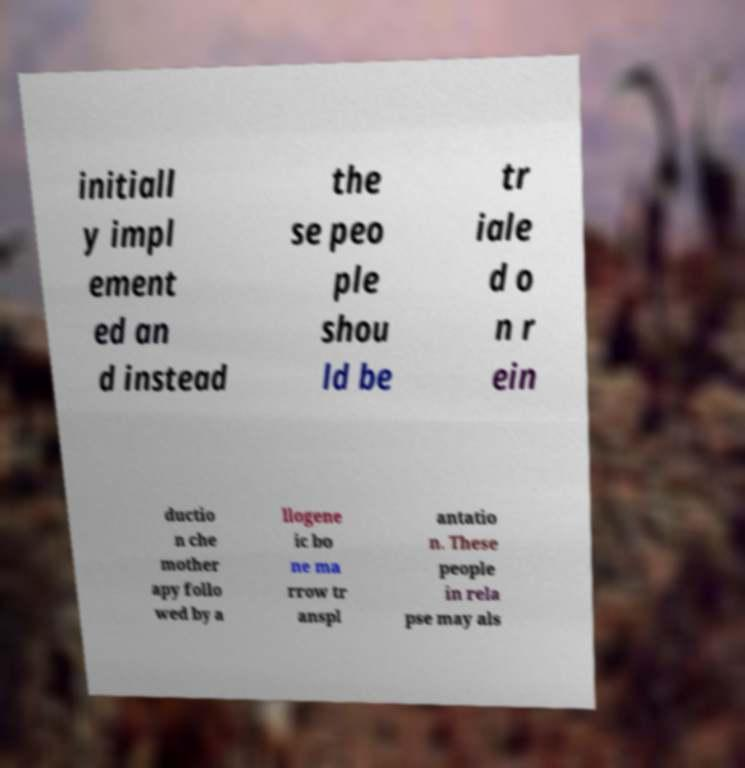There's text embedded in this image that I need extracted. Can you transcribe it verbatim? initiall y impl ement ed an d instead the se peo ple shou ld be tr iale d o n r ein ductio n che mother apy follo wed by a llogene ic bo ne ma rrow tr anspl antatio n. These people in rela pse may als 